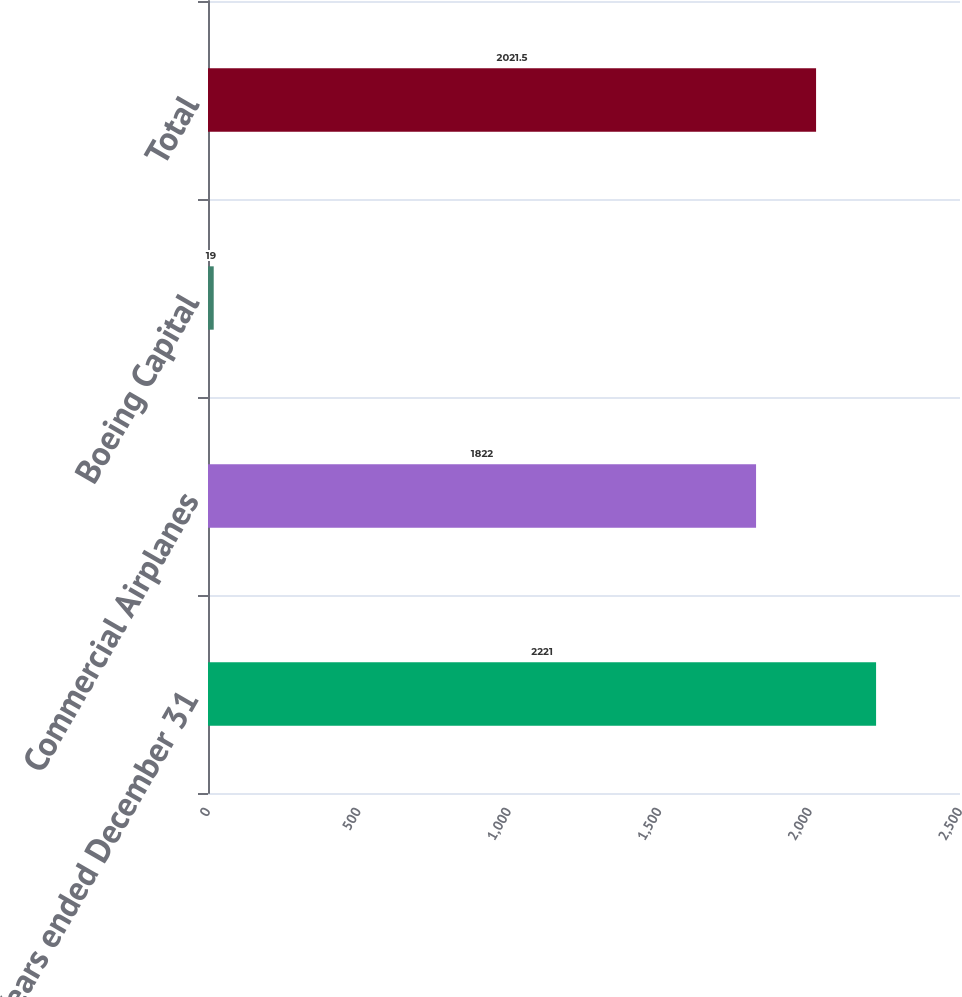<chart> <loc_0><loc_0><loc_500><loc_500><bar_chart><fcel>Years ended December 31<fcel>Commercial Airplanes<fcel>Boeing Capital<fcel>Total<nl><fcel>2221<fcel>1822<fcel>19<fcel>2021.5<nl></chart> 